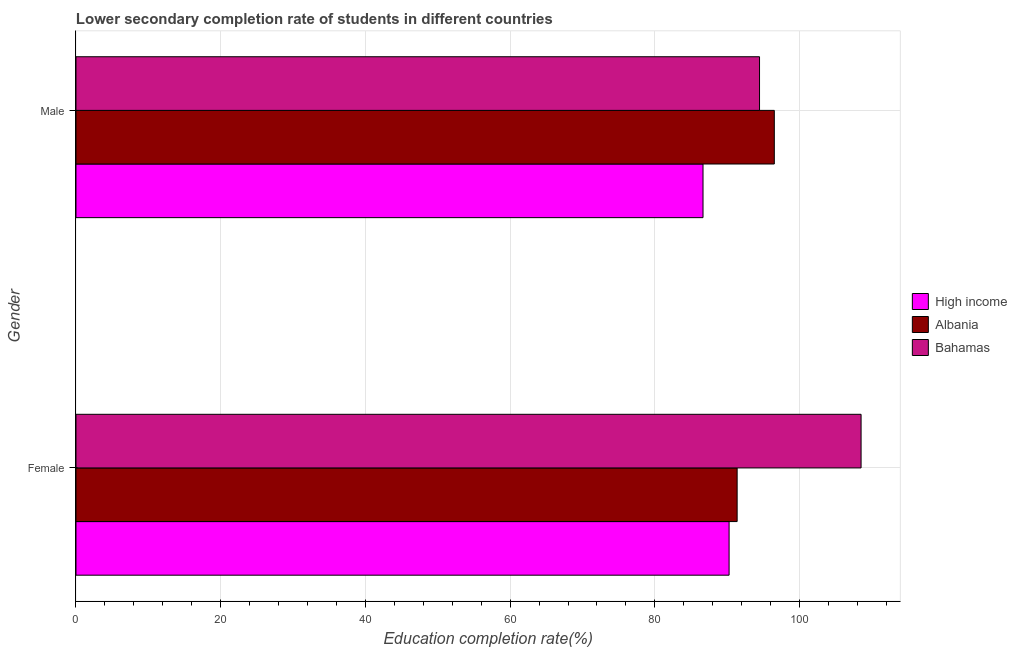Are the number of bars per tick equal to the number of legend labels?
Provide a succinct answer. Yes. How many bars are there on the 1st tick from the top?
Provide a succinct answer. 3. What is the label of the 2nd group of bars from the top?
Your response must be concise. Female. What is the education completion rate of male students in Bahamas?
Your answer should be compact. 94.47. Across all countries, what is the maximum education completion rate of female students?
Provide a succinct answer. 108.5. Across all countries, what is the minimum education completion rate of female students?
Keep it short and to the point. 90.26. In which country was the education completion rate of male students maximum?
Give a very brief answer. Albania. In which country was the education completion rate of male students minimum?
Give a very brief answer. High income. What is the total education completion rate of male students in the graph?
Your response must be concise. 277.63. What is the difference between the education completion rate of female students in Bahamas and that in Albania?
Provide a short and direct response. 17.13. What is the difference between the education completion rate of male students in Albania and the education completion rate of female students in High income?
Offer a very short reply. 6.25. What is the average education completion rate of female students per country?
Offer a very short reply. 96.71. What is the difference between the education completion rate of male students and education completion rate of female students in Bahamas?
Give a very brief answer. -14.04. In how many countries, is the education completion rate of male students greater than 12 %?
Your answer should be compact. 3. What is the ratio of the education completion rate of female students in Bahamas to that in High income?
Offer a terse response. 1.2. Is the education completion rate of female students in Bahamas less than that in Albania?
Offer a very short reply. No. In how many countries, is the education completion rate of male students greater than the average education completion rate of male students taken over all countries?
Your answer should be compact. 2. How many bars are there?
Give a very brief answer. 6. Does the graph contain grids?
Provide a short and direct response. Yes. Where does the legend appear in the graph?
Ensure brevity in your answer.  Center right. What is the title of the graph?
Ensure brevity in your answer.  Lower secondary completion rate of students in different countries. Does "Monaco" appear as one of the legend labels in the graph?
Offer a very short reply. No. What is the label or title of the X-axis?
Provide a short and direct response. Education completion rate(%). What is the label or title of the Y-axis?
Provide a succinct answer. Gender. What is the Education completion rate(%) in High income in Female?
Keep it short and to the point. 90.26. What is the Education completion rate(%) of Albania in Female?
Provide a succinct answer. 91.37. What is the Education completion rate(%) in Bahamas in Female?
Your answer should be compact. 108.5. What is the Education completion rate(%) in High income in Male?
Give a very brief answer. 86.66. What is the Education completion rate(%) in Albania in Male?
Offer a terse response. 96.51. What is the Education completion rate(%) of Bahamas in Male?
Give a very brief answer. 94.47. Across all Gender, what is the maximum Education completion rate(%) of High income?
Your answer should be very brief. 90.26. Across all Gender, what is the maximum Education completion rate(%) of Albania?
Your answer should be compact. 96.51. Across all Gender, what is the maximum Education completion rate(%) in Bahamas?
Your response must be concise. 108.5. Across all Gender, what is the minimum Education completion rate(%) of High income?
Give a very brief answer. 86.66. Across all Gender, what is the minimum Education completion rate(%) in Albania?
Your answer should be very brief. 91.37. Across all Gender, what is the minimum Education completion rate(%) in Bahamas?
Offer a terse response. 94.47. What is the total Education completion rate(%) in High income in the graph?
Make the answer very short. 176.92. What is the total Education completion rate(%) of Albania in the graph?
Provide a succinct answer. 187.88. What is the total Education completion rate(%) in Bahamas in the graph?
Your answer should be very brief. 202.97. What is the difference between the Education completion rate(%) of High income in Female and that in Male?
Your answer should be very brief. 3.6. What is the difference between the Education completion rate(%) in Albania in Female and that in Male?
Your answer should be very brief. -5.14. What is the difference between the Education completion rate(%) in Bahamas in Female and that in Male?
Give a very brief answer. 14.04. What is the difference between the Education completion rate(%) of High income in Female and the Education completion rate(%) of Albania in Male?
Your answer should be very brief. -6.25. What is the difference between the Education completion rate(%) in High income in Female and the Education completion rate(%) in Bahamas in Male?
Give a very brief answer. -4.21. What is the difference between the Education completion rate(%) in Albania in Female and the Education completion rate(%) in Bahamas in Male?
Provide a short and direct response. -3.09. What is the average Education completion rate(%) in High income per Gender?
Your answer should be very brief. 88.46. What is the average Education completion rate(%) of Albania per Gender?
Offer a terse response. 93.94. What is the average Education completion rate(%) of Bahamas per Gender?
Your response must be concise. 101.48. What is the difference between the Education completion rate(%) in High income and Education completion rate(%) in Albania in Female?
Offer a terse response. -1.11. What is the difference between the Education completion rate(%) of High income and Education completion rate(%) of Bahamas in Female?
Keep it short and to the point. -18.24. What is the difference between the Education completion rate(%) of Albania and Education completion rate(%) of Bahamas in Female?
Keep it short and to the point. -17.13. What is the difference between the Education completion rate(%) of High income and Education completion rate(%) of Albania in Male?
Provide a short and direct response. -9.85. What is the difference between the Education completion rate(%) in High income and Education completion rate(%) in Bahamas in Male?
Make the answer very short. -7.81. What is the difference between the Education completion rate(%) in Albania and Education completion rate(%) in Bahamas in Male?
Your answer should be very brief. 2.04. What is the ratio of the Education completion rate(%) of High income in Female to that in Male?
Offer a terse response. 1.04. What is the ratio of the Education completion rate(%) in Albania in Female to that in Male?
Provide a succinct answer. 0.95. What is the ratio of the Education completion rate(%) in Bahamas in Female to that in Male?
Offer a terse response. 1.15. What is the difference between the highest and the second highest Education completion rate(%) in High income?
Your answer should be very brief. 3.6. What is the difference between the highest and the second highest Education completion rate(%) of Albania?
Your answer should be very brief. 5.14. What is the difference between the highest and the second highest Education completion rate(%) of Bahamas?
Give a very brief answer. 14.04. What is the difference between the highest and the lowest Education completion rate(%) in High income?
Provide a succinct answer. 3.6. What is the difference between the highest and the lowest Education completion rate(%) of Albania?
Your answer should be compact. 5.14. What is the difference between the highest and the lowest Education completion rate(%) in Bahamas?
Provide a succinct answer. 14.04. 